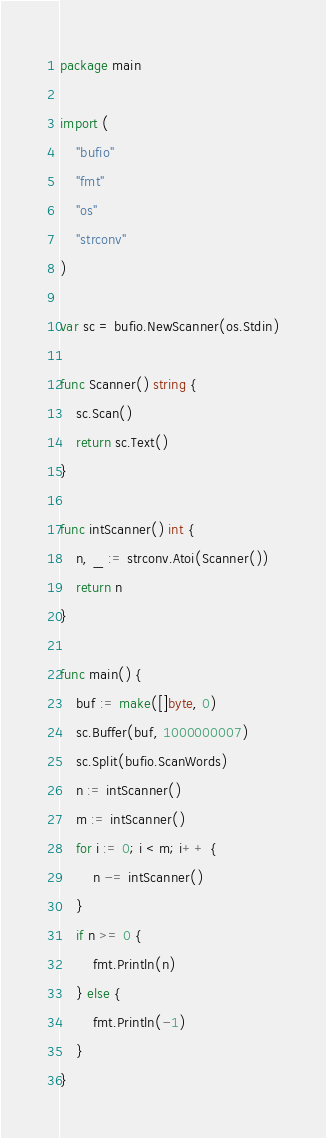Convert code to text. <code><loc_0><loc_0><loc_500><loc_500><_Go_>package main

import (
	"bufio"
	"fmt"
	"os"
	"strconv"
)

var sc = bufio.NewScanner(os.Stdin)

func Scanner() string {
	sc.Scan()
	return sc.Text()
}

func intScanner() int {
	n, _ := strconv.Atoi(Scanner())
	return n
}

func main() {
	buf := make([]byte, 0)
	sc.Buffer(buf, 1000000007)
	sc.Split(bufio.ScanWords)
	n := intScanner()
	m := intScanner()
	for i := 0; i < m; i++ {
		n -= intScanner()
	}
	if n >= 0 {
		fmt.Println(n)
	} else {
		fmt.Println(-1)
	}
}
</code> 